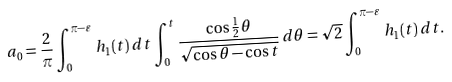Convert formula to latex. <formula><loc_0><loc_0><loc_500><loc_500>a _ { 0 } = \frac { 2 } { \pi } \int _ { 0 } ^ { \pi - \varepsilon } h _ { 1 } ( t ) \, d t \int _ { 0 } ^ { t } \frac { \cos \frac { 1 } { 2 } \theta } { \sqrt { \cos \theta - \cos t } } \, d \theta = \sqrt { 2 } \int _ { 0 } ^ { \pi - \varepsilon } h _ { 1 } ( t ) \, d t .</formula> 